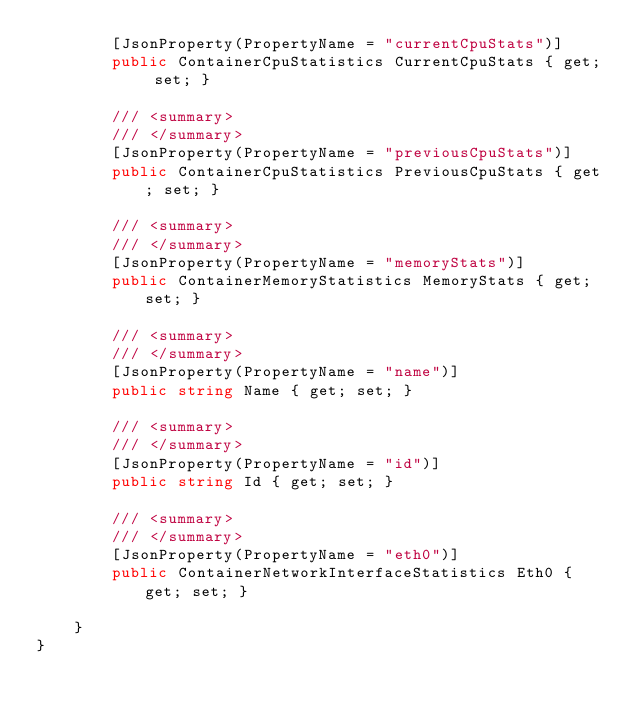<code> <loc_0><loc_0><loc_500><loc_500><_C#_>        [JsonProperty(PropertyName = "currentCpuStats")]
        public ContainerCpuStatistics CurrentCpuStats { get; set; }

        /// <summary>
        /// </summary>
        [JsonProperty(PropertyName = "previousCpuStats")]
        public ContainerCpuStatistics PreviousCpuStats { get; set; }

        /// <summary>
        /// </summary>
        [JsonProperty(PropertyName = "memoryStats")]
        public ContainerMemoryStatistics MemoryStats { get; set; }

        /// <summary>
        /// </summary>
        [JsonProperty(PropertyName = "name")]
        public string Name { get; set; }

        /// <summary>
        /// </summary>
        [JsonProperty(PropertyName = "id")]
        public string Id { get; set; }

        /// <summary>
        /// </summary>
        [JsonProperty(PropertyName = "eth0")]
        public ContainerNetworkInterfaceStatistics Eth0 { get; set; }

    }
}
</code> 